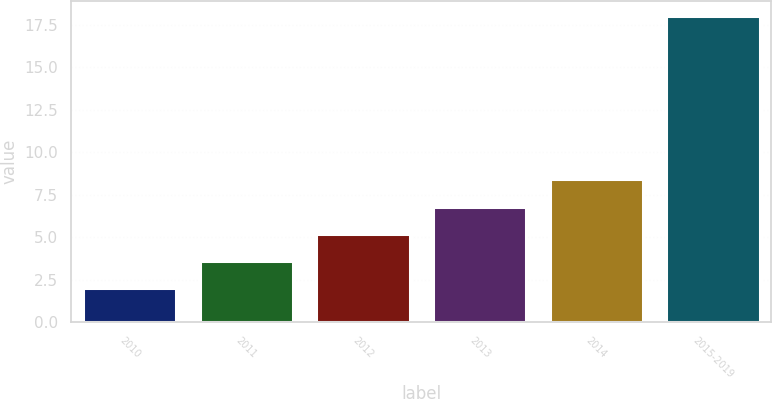Convert chart to OTSL. <chart><loc_0><loc_0><loc_500><loc_500><bar_chart><fcel>2010<fcel>2011<fcel>2012<fcel>2013<fcel>2014<fcel>2015-2019<nl><fcel>2<fcel>3.6<fcel>5.2<fcel>6.8<fcel>8.4<fcel>18<nl></chart> 